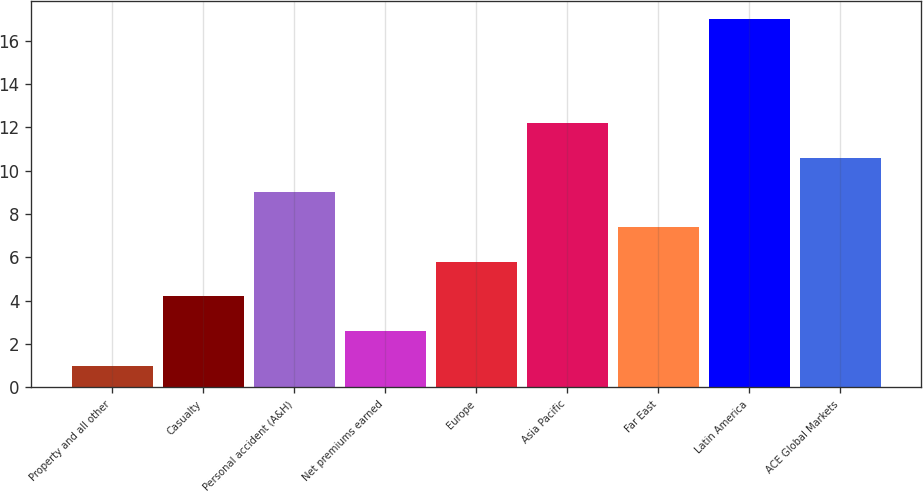Convert chart to OTSL. <chart><loc_0><loc_0><loc_500><loc_500><bar_chart><fcel>Property and all other<fcel>Casualty<fcel>Personal accident (A&H)<fcel>Net premiums earned<fcel>Europe<fcel>Asia Pacific<fcel>Far East<fcel>Latin America<fcel>ACE Global Markets<nl><fcel>1<fcel>4.2<fcel>9<fcel>2.6<fcel>5.8<fcel>12.2<fcel>7.4<fcel>17<fcel>10.6<nl></chart> 